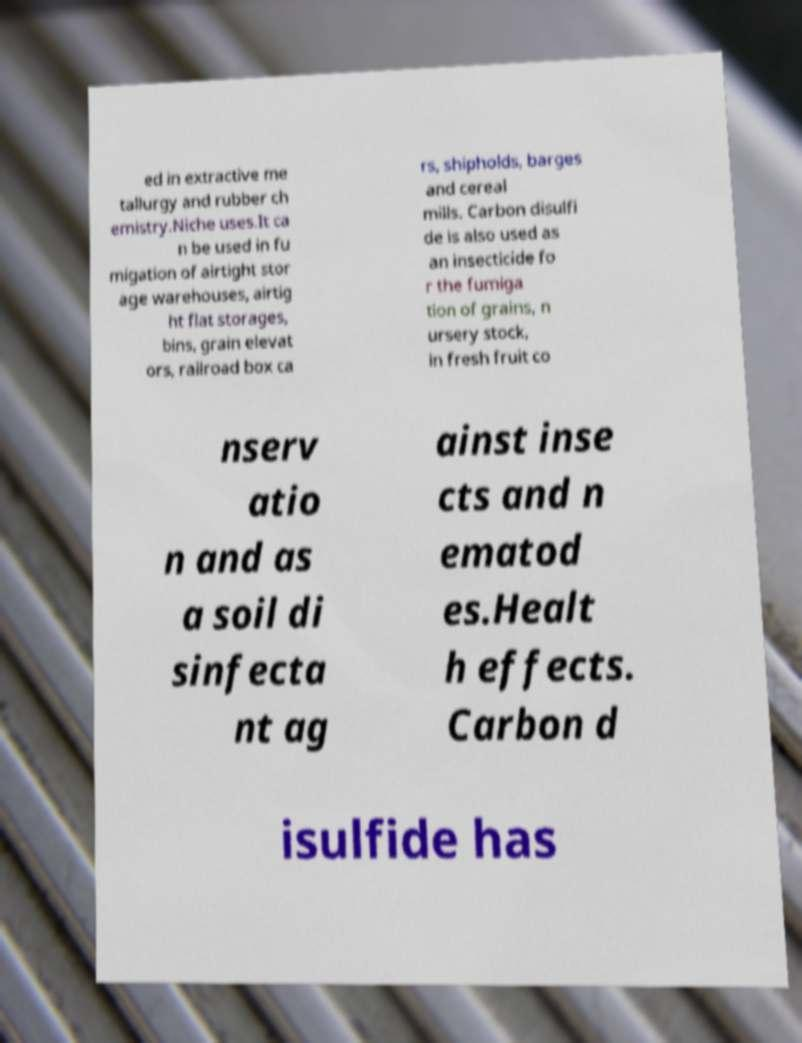Can you accurately transcribe the text from the provided image for me? ed in extractive me tallurgy and rubber ch emistry.Niche uses.It ca n be used in fu migation of airtight stor age warehouses, airtig ht flat storages, bins, grain elevat ors, railroad box ca rs, shipholds, barges and cereal mills. Carbon disulfi de is also used as an insecticide fo r the fumiga tion of grains, n ursery stock, in fresh fruit co nserv atio n and as a soil di sinfecta nt ag ainst inse cts and n ematod es.Healt h effects. Carbon d isulfide has 